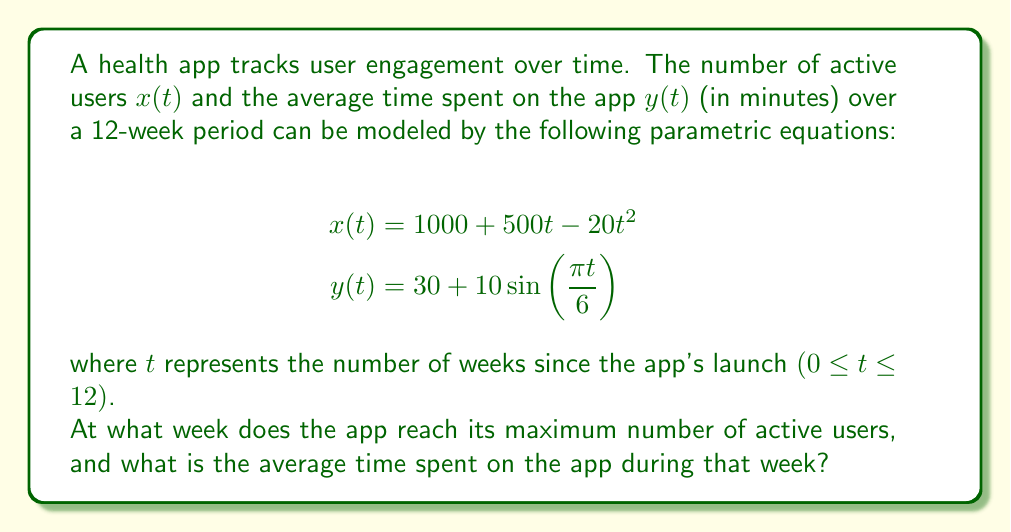Provide a solution to this math problem. To solve this problem, we need to follow these steps:

1. Find the maximum number of active users by determining when $x(t)$ reaches its peak.
2. Calculate the corresponding time $t$ for the maximum.
3. Use this time $t$ to calculate the average time spent on the app $y(t)$.

Step 1: To find the maximum of $x(t)$, we need to find where its derivative equals zero:

$$\frac{dx}{dt} = 500 - 40t$$

Set this equal to zero and solve for $t$:

$$500 - 40t = 0$$
$$-40t = -500$$
$$t = \frac{500}{40} = 12.5$$

The function reaches its maximum at $t = 12.5$ weeks. However, since our domain is restricted to $0 \leq t \leq 12$, the maximum within our range occurs at $t = 12$ weeks.

Step 2: The maximum occurs at week 12.

Step 3: Calculate $y(12)$:

$$y(12) = 30 + 10\sin(\frac{\pi \cdot 12}{6})$$
$$= 30 + 10\sin(2\pi)$$
$$= 30 + 10 \cdot 0$$
$$= 30$$

Therefore, at week 12, when the number of active users is at its maximum, the average time spent on the app is 30 minutes.
Answer: The app reaches its maximum number of active users at week 12, and the average time spent on the app during that week is 30 minutes. 